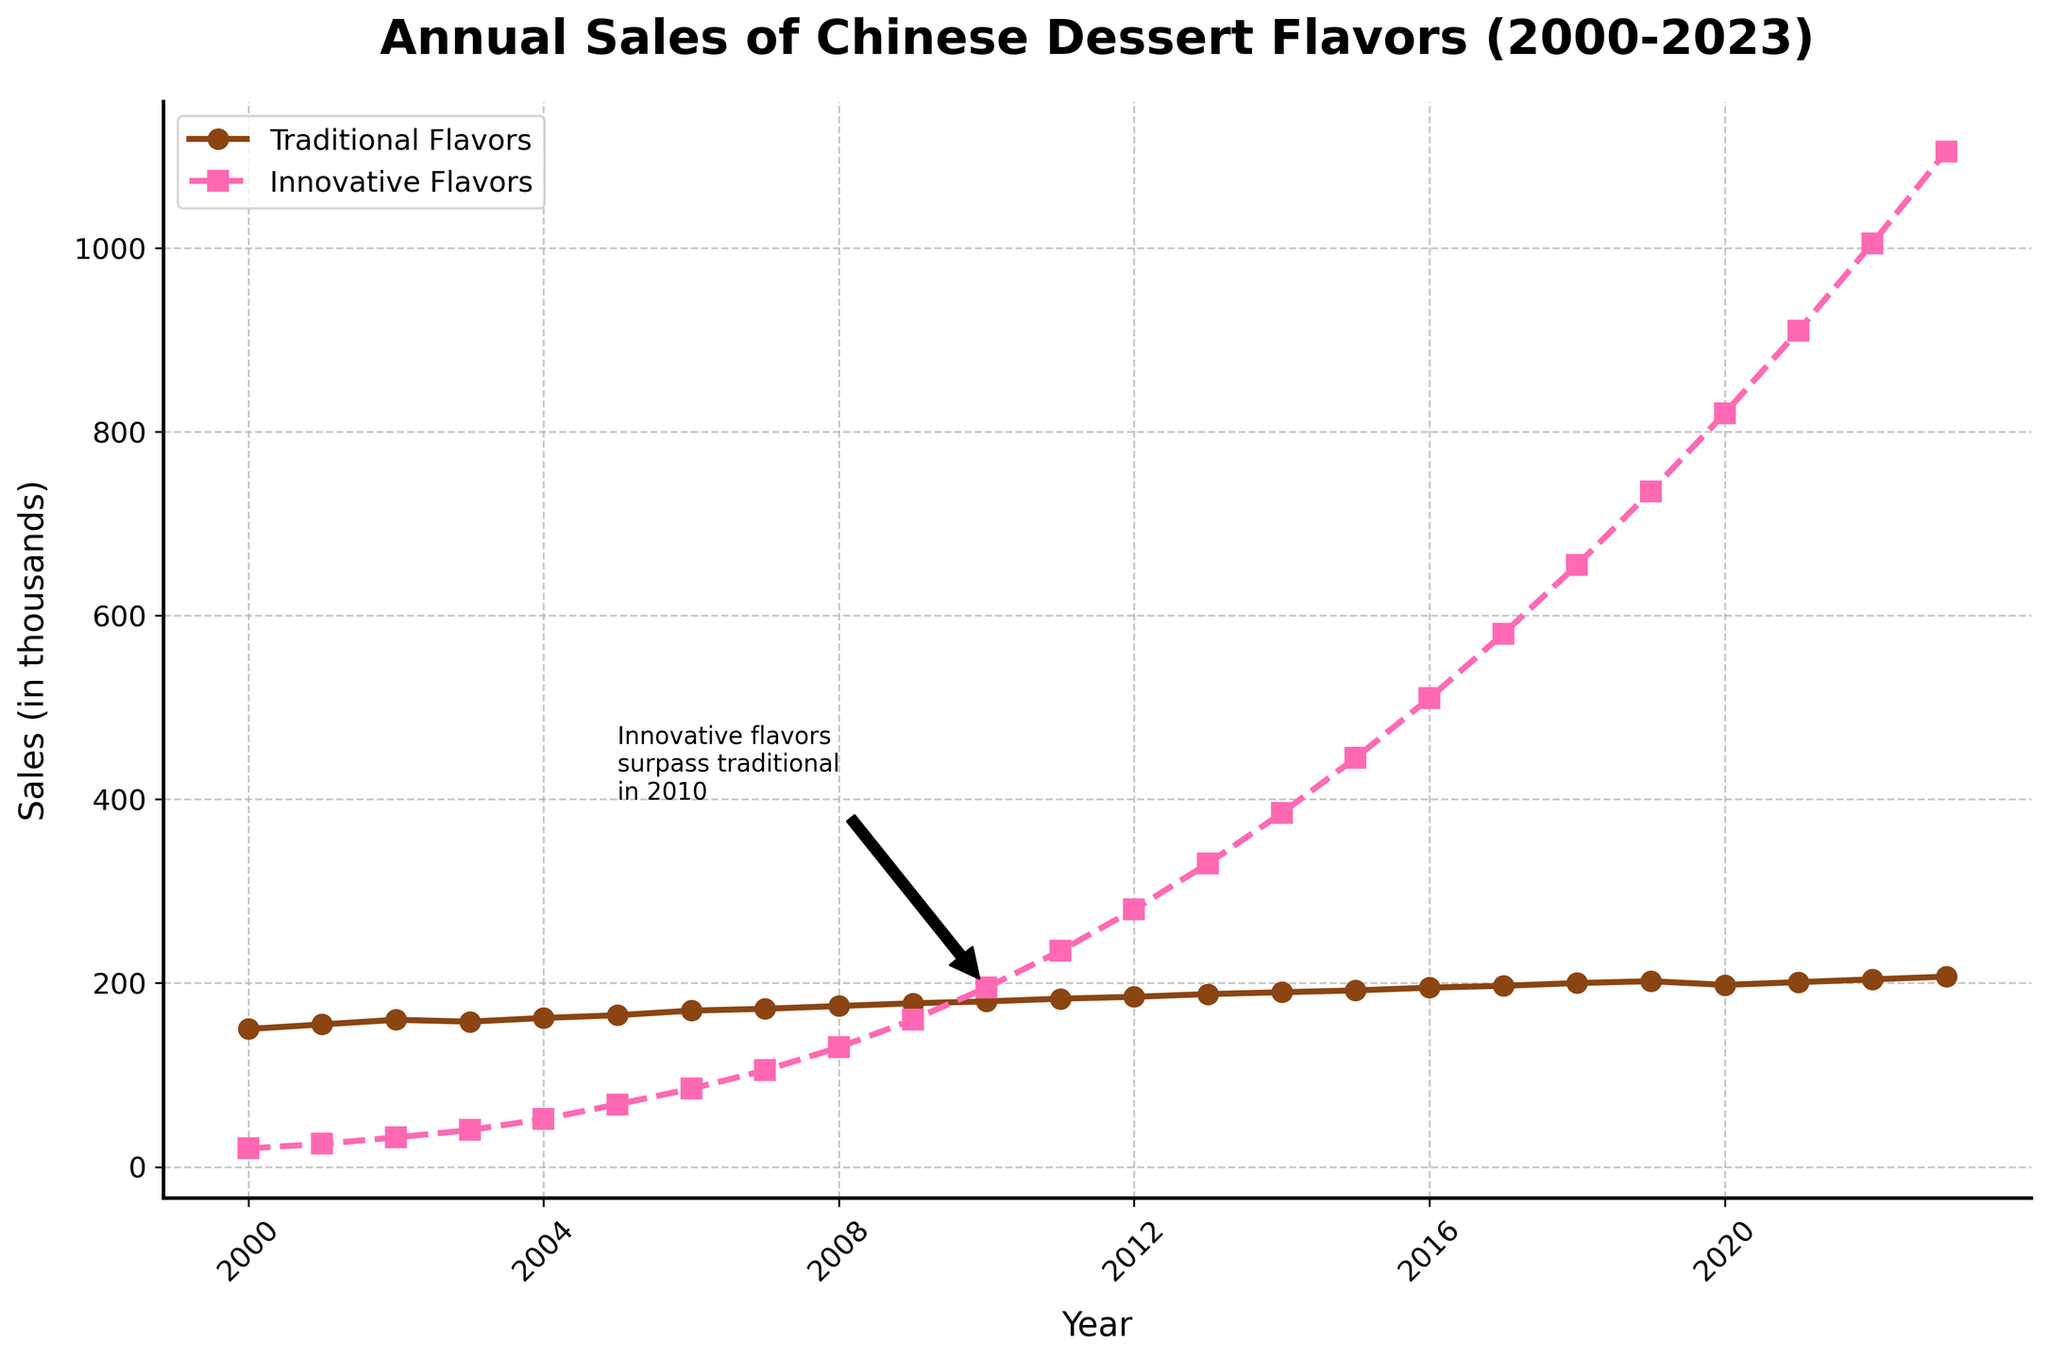What year did innovative flavors surpass traditional flavors in sales? The figure includes an annotation that specifically marks the year when innovative flavors surpassed traditional flavors. According to the annotation, this happened in 2010.
Answer: 2010 What's the difference in sales between traditional and innovative flavors in 2023? The sales for traditional flavors in 2023 are 207, and for innovative flavors, they are 1105. The difference is calculated as 1105 - 207.
Answer: 898 Which flavor type showed a faster increase in sales over the period from 2000 to 2023? By examining the slopes of the lines, the innovative flavors line shows a steeper and more consistent rise compared to the traditional flavors line.
Answer: Innovative flavors How does the sales trend for traditional flavors from 2000 to 2023 look compared to the sales trend for innovative flavors? The traditional flavors show a slightly increasing but relatively stable trend, whereas the innovative flavors show a rapidly increasing trend throughout the years.
Answer: Traditional: Stable increase, Innovative: Rapid increase What can you infer about the popularity of innovative flavors compared to traditional ones by 2023? By 2023, the sales of innovative flavors have significantly surpassed those of traditional flavors, indicating a shift in consumer preference. This can be inferred from the much higher value for innovative flavors in 2023.
Answer: Innovative flavors are more popular In which year did both traditional and innovative flavors see the sharpest increase in sales? By examining the year-to-year sales difference for both trends, the sharpest increase for traditional flavors is less pronounced. For innovative flavors, the sharpest increase happened between 2021 and 2022, where the sales rose from 910 to 1005.
Answer: Innovative: 2021-2022 What visual cue indicates a notable event in the sales trend for innovative flavors around 2010? The figure includes an annotation with an arrow pointing to the year 2010, highlighting that innovative flavors surpassed traditional flavors that year.
Answer: Annotation near 2010 By how much did the sales of traditional flavors increase between 2000 and 2023? The sales of traditional flavors in 2000 were 150 and in 2023 were 207. The increase is calculated as 207 - 150.
Answer: 57 How does the grid style help in interpreting the sales trends from 2000 to 2023? The grid lines, styled with a dashed pattern and set at intervals, provide a clearer visual reference for comparing sales values across different years, making trends more apparent.
Answer: Enhanced trend visibility 